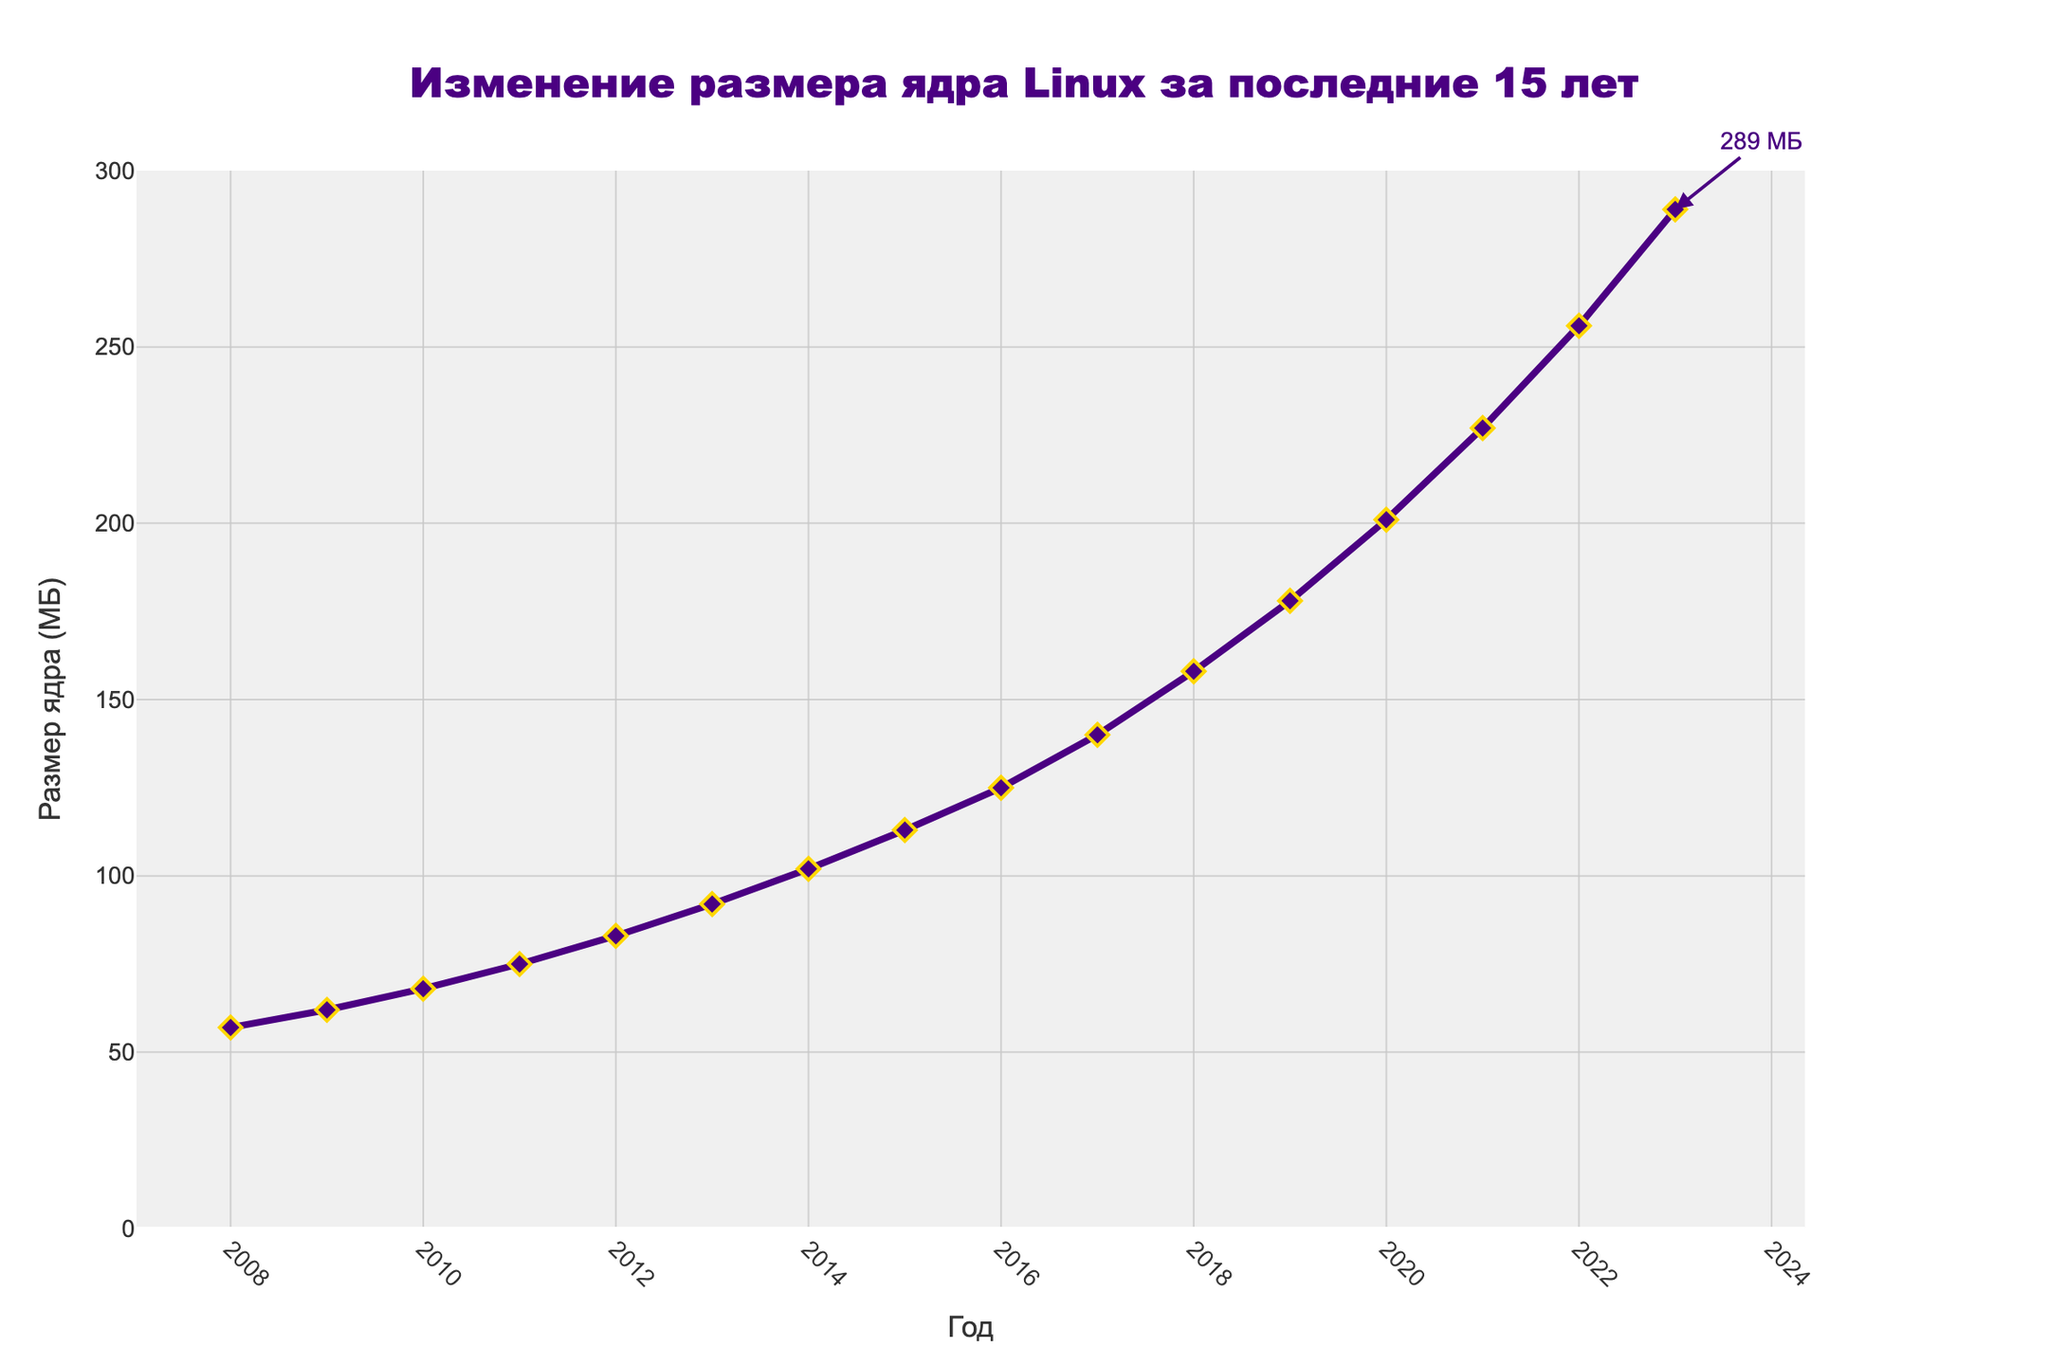What's the percentage increase in the kernel size from 2008 to 2023? First, find the initial and final kernel sizes. The kernel size in 2008 is 57 MB and in 2023 is 289 MB. The increase in kernel size is 289 - 57 = 232 MB. To find the percentage increase, use the formula: (Increase / Initial size) * 100. So, (232 / 57) * 100 ≈ 406.14%
Answer: 406.14% By how much did the kernel size increase from 2015 to 2018? Check the kernel size in 2015 and 2018. In 2015, it's 113 MB, and in 2018, it's 158 MB. The increase is 158 - 113 = 45 MB
Answer: 45 MB What is the average yearly increase in the kernel size from 2008 to 2023? First, find the total increase: 289 MB (2023) - 57 MB (2008) = 232 MB. The period is 2023 - 2008 = 15 years. Divide the total increase by the number of years: 232 MB / 15 years ≈ 15.47 MB/year
Answer: 15.47 MB/year Compare the kernel size in 2010 and 2020. How many times larger is the 2020 kernel size compared to 2010? The kernel size in 2010 is 68 MB, and in 2020 it's 201 MB. Divide the 2020 size by the 2010 size: 201 / 68 ≈ 2.96 times larger
Answer: 2.96 times What is the highest annual increase in kernel size within the given period? Scan through the data and find the largest year-over-year increase. From 2022 to 2023, the increase is 289 - 256 = 33 MB, which is the highest in the dataset
Answer: 33 MB How does the kernel size change visually from 2008 to 2023? The graph line consistently rises from left to right, starting from 57 MB in 2008 to 289 MB in 2023, with the data points marked as diamonds and the line colored in indigo
Answer: It steadily increases What is the kernel size in the midpoint year of the dataset, 2015? Given the time range from 2008 to 2023, the midpoint year is 2015. The kernel size in 2015 is marked as 113 MB
Answer: 113 MB How many times did the kernel size increase by more than 20 MB from one year to the next? Review the data year by year and count increments more than 20 MB. These are between 2017-2018 (18 MB), 2018-2019 (20 MB), 2019-2020 (23 MB), and 2020-2021 (26 MB) totaling 4 times
Answer: 4 times 